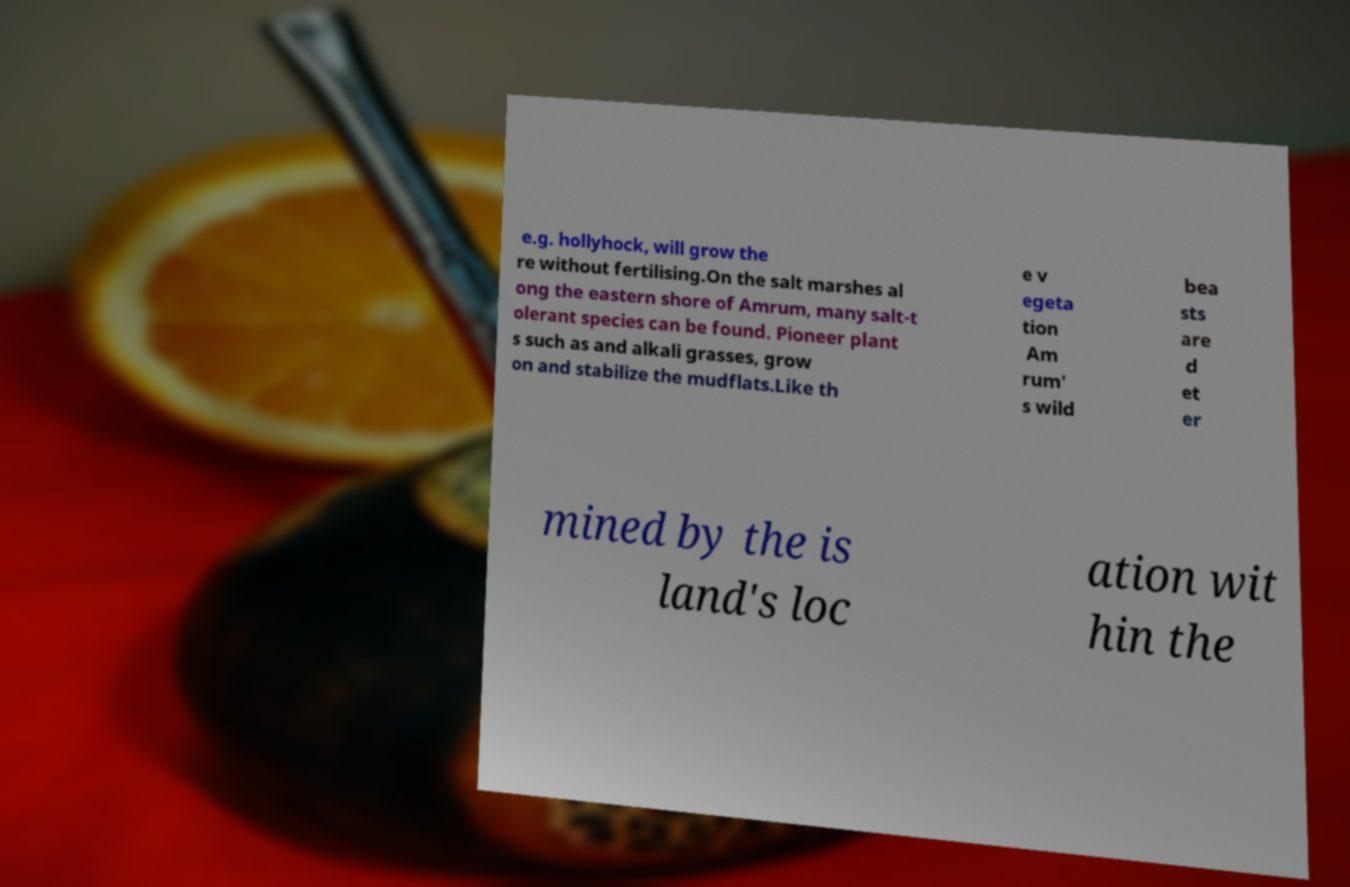Please read and relay the text visible in this image. What does it say? e.g. hollyhock, will grow the re without fertilising.On the salt marshes al ong the eastern shore of Amrum, many salt-t olerant species can be found. Pioneer plant s such as and alkali grasses, grow on and stabilize the mudflats.Like th e v egeta tion Am rum' s wild bea sts are d et er mined by the is land's loc ation wit hin the 